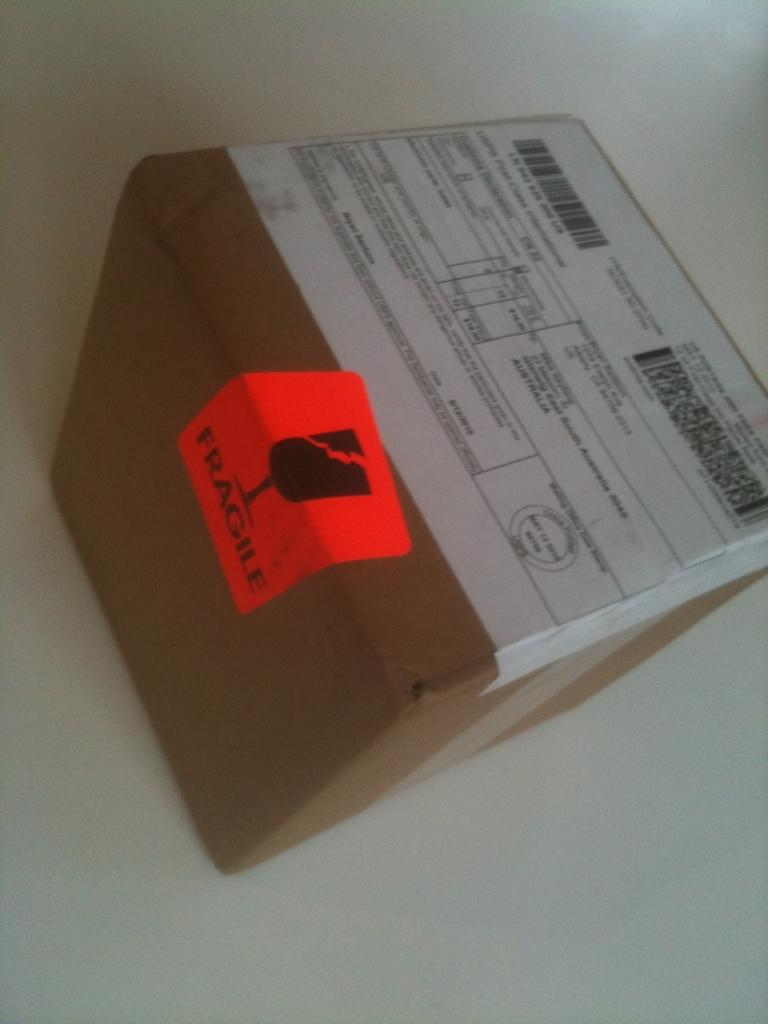<image>
Relay a brief, clear account of the picture shown. A brown box with a shipping label attached is marked fragile. 